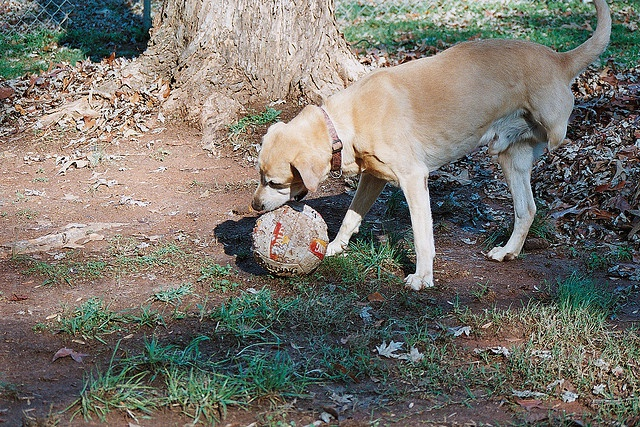Describe the objects in this image and their specific colors. I can see dog in gray, darkgray, lightgray, and tan tones and sports ball in gray, darkgray, lightgray, and black tones in this image. 